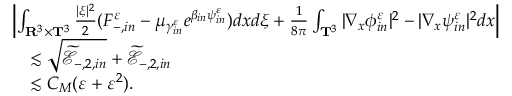Convert formula to latex. <formula><loc_0><loc_0><loc_500><loc_500>\begin{array} { r l } & { \left | \int _ { \mathbf R ^ { 3 } \times \mathbf T ^ { 3 } } \frac { | \xi | ^ { 2 } } { 2 } ( F _ { - , i n } ^ { \varepsilon } - \mu _ { \gamma _ { i n } ^ { \varepsilon } } e ^ { \beta _ { i n } \psi _ { i n } ^ { \varepsilon } } ) d x d \xi + \frac { 1 } { 8 \pi } \int _ { \mathbf T ^ { 3 } } | \nabla _ { x } \phi _ { i n } ^ { \varepsilon } | ^ { 2 } - | \nabla _ { x } \psi _ { i n } ^ { \varepsilon } | ^ { 2 } d x \right | } \\ & { \quad \lesssim \sqrt { \widetilde { \ m a t h s c r E } _ { - , 2 , i n } } + \widetilde { \ m a t h s c r E } _ { - , 2 , i n } } \\ & { \quad \lesssim C _ { M } ( \varepsilon + \varepsilon ^ { 2 } ) . } \end{array}</formula> 